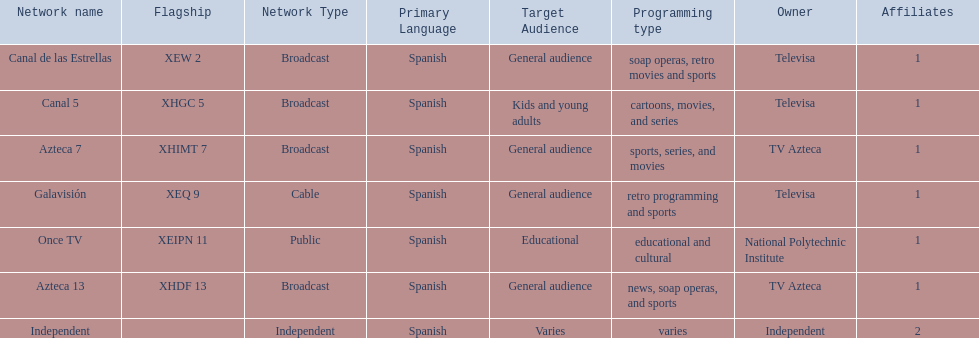Name a station that shows sports but is not televisa. Azteca 7. 